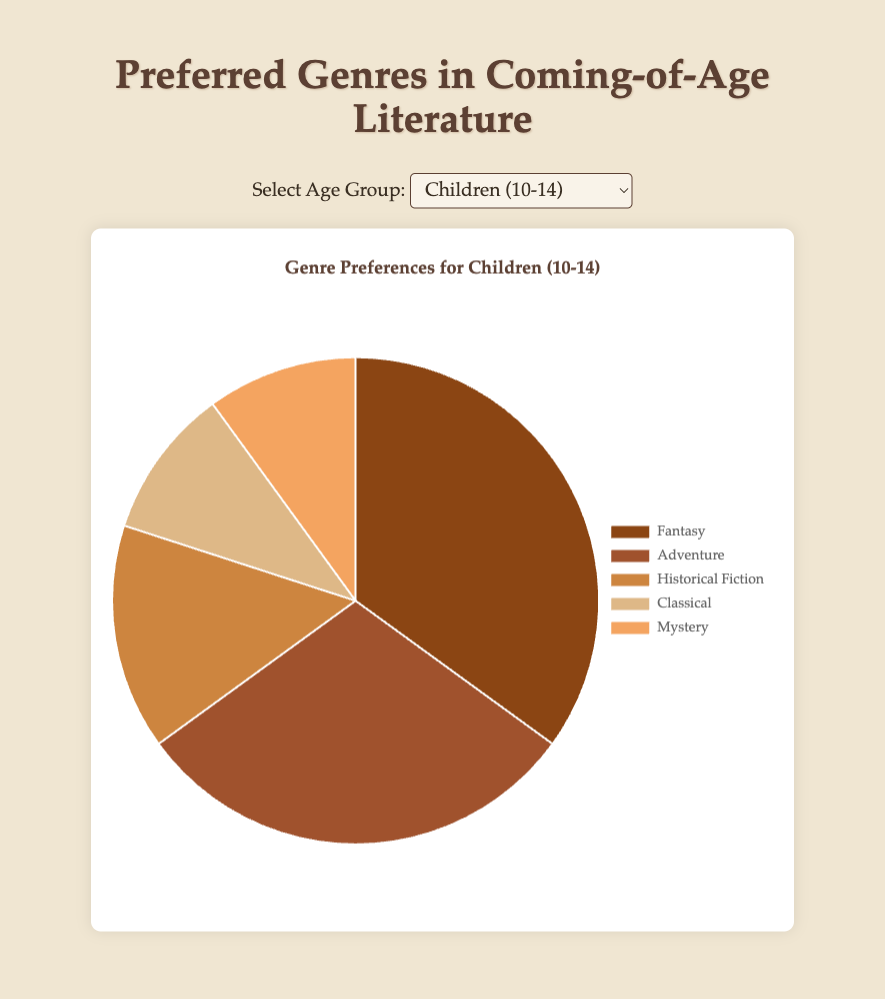Which age group has the highest percentage of readers who prefer 'Fantasy'? By observing the slices representing 'Fantasy' in all age groups, 'Children (10-14)' has the largest slice.
Answer: Children (10-14) Which genre is equally preferred by both 'Teens (15-18)' and 'Children (10-14)'? Compare percentages across both age groups to find that 'Historical Fiction' and 'Mystery' are the same at 10%.
Answer: Historical Fiction, Mystery In the 'Adults (26-45)' age group, which two genres combined make up the largest share? Summing percentages for genres in the 'Adults (26-45)' group, 'Historical Fiction' (20%) + 'Classical' (25%) = 45%, which is the largest combined share.
Answer: Historical Fiction, Classical What is the most popular genre among 'Older Adults (46+)'? Observing the largest slice for 'Older Adults (46+)' reveals 'Classical' as the most significant.
Answer: Classical Which genre shows a noticeable trend of decreasing preference with increasing age? 'Fantasy' preference decreases consistently from 35% in children to 10% in older adults.
Answer: Fantasy How does the preference for 'Classical' literature vary between 'Teens (15-18)' and 'Adults (26-45)'? Comparing 'Teens (15-18)' (25%) to 'Adults (26-45)' (25%), the preference for 'Classical' literature is the same.
Answer: Equal What is the difference in preference for 'Romance' between 'Young Adults (19-25)' and 'Teens (15-18)'? 'Young Adults (19-25)' is 10%, and 'Teens (15-18)' is 10%. The difference is 0%.
Answer: 0% Which age group has the lowest percentage of 'Science Fiction' readers, and what is that percentage? By comparing 'Science Fiction' across all age groups, 'Adults (26-45)' has the lowest percentage of 5%.
Answer: Adults (26-45), 5% What is the sum of the percentages for 'Mystery' and 'Romance' among 'Teens (15-18)'? 'Mystery' is 10% and 'Romance' is 10%, summing to 20% for 'Teens (15-18)'.
Answer: 20% Which genres have the same preference percentage of 10% among 'Children (10-14)'? Observing the slices for 'Children (10-14)', both 'Classical' and 'Mystery' are 10%.
Answer: Classical, Mystery 